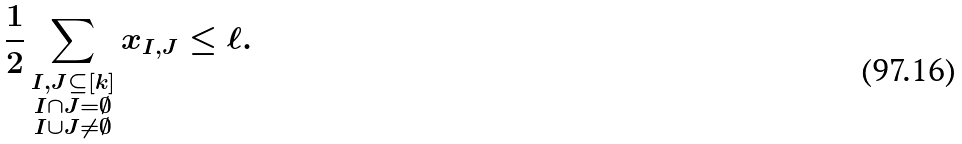Convert formula to latex. <formula><loc_0><loc_0><loc_500><loc_500>\frac { 1 } { 2 } \sum _ { \substack { I , J \subseteq [ k ] \\ I \cap J = \emptyset \\ I \cup J \neq \emptyset } } x _ { I , J } \leq \ell .</formula> 